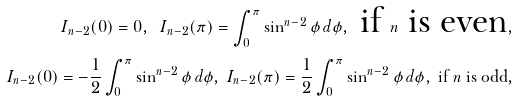Convert formula to latex. <formula><loc_0><loc_0><loc_500><loc_500>I _ { n - 2 } ( 0 ) = 0 , \ I _ { n - 2 } ( \pi ) = \int _ { 0 } ^ { \pi } \sin ^ { n - 2 } \phi \, d \phi , \text { if } n \text { is even} , \\ I _ { n - 2 } ( 0 ) = - \frac { 1 } { 2 } \int _ { 0 } ^ { \pi } \sin ^ { n - 2 } \phi \, d \phi , \ I _ { n - 2 } ( \pi ) = \frac { 1 } { 2 } \int _ { 0 } ^ { \pi } \sin ^ { n - 2 } \phi \, d \phi , \text { if } n \text { is odd} ,</formula> 